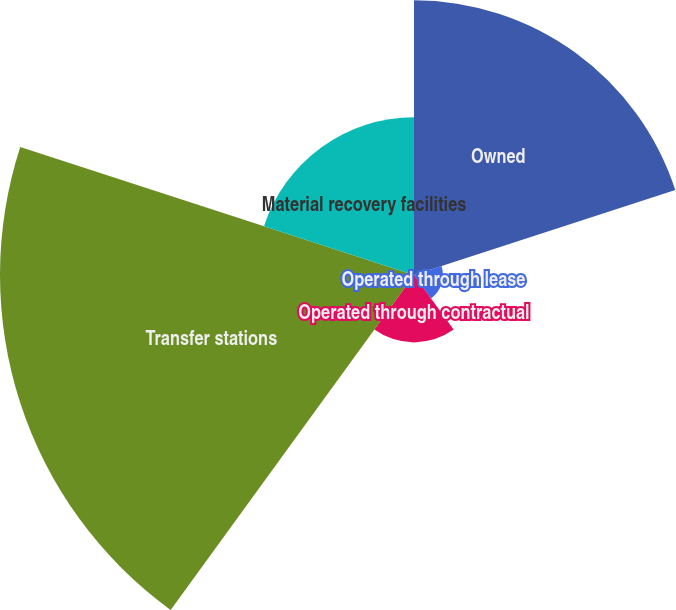<chart> <loc_0><loc_0><loc_500><loc_500><pie_chart><fcel>Owned<fcel>Operated through lease<fcel>Operated through contractual<fcel>Transfer stations<fcel>Material recovery facilities<nl><fcel>29.14%<fcel>3.07%<fcel>7.15%<fcel>43.91%<fcel>16.73%<nl></chart> 